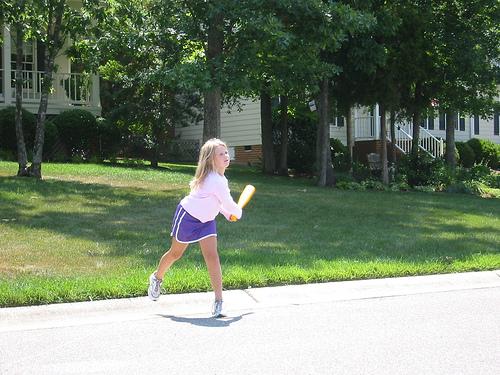What sport is he playing?
Quick response, please. Baseball. Is it raining?
Concise answer only. No. Does she look enthusiastic?
Keep it brief. Yes. How many trees are shown?
Be succinct. 12. What color jacket does the girl with the ponytail have on?
Be succinct. White. What are these people holding?
Write a very short answer. Bat. What is the weather like?
Keep it brief. Sunny. What is she swinging?
Give a very brief answer. Bat. 